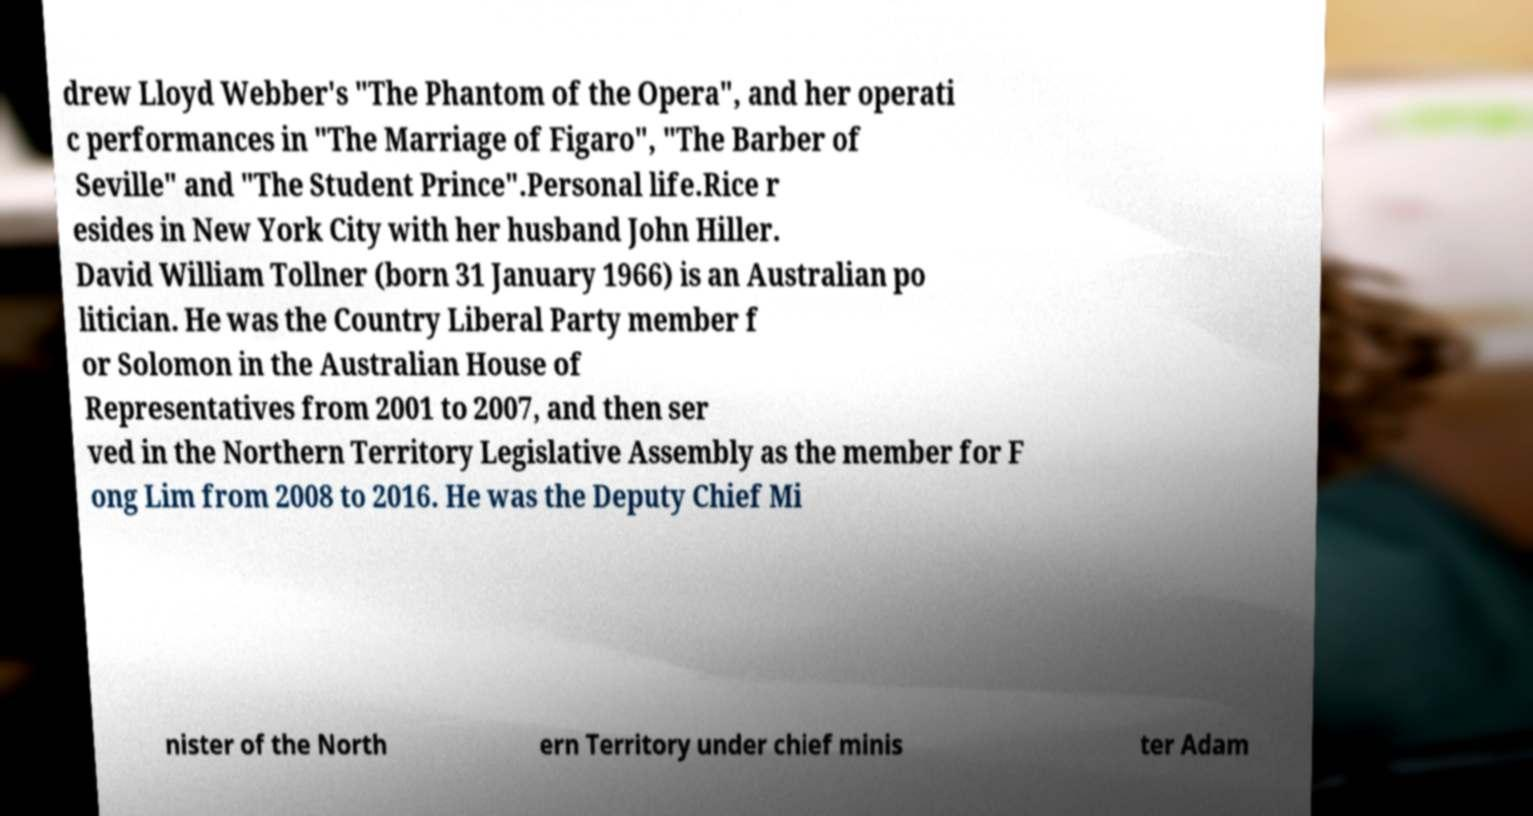I need the written content from this picture converted into text. Can you do that? drew Lloyd Webber's "The Phantom of the Opera", and her operati c performances in "The Marriage of Figaro", "The Barber of Seville" and "The Student Prince".Personal life.Rice r esides in New York City with her husband John Hiller. David William Tollner (born 31 January 1966) is an Australian po litician. He was the Country Liberal Party member f or Solomon in the Australian House of Representatives from 2001 to 2007, and then ser ved in the Northern Territory Legislative Assembly as the member for F ong Lim from 2008 to 2016. He was the Deputy Chief Mi nister of the North ern Territory under chief minis ter Adam 